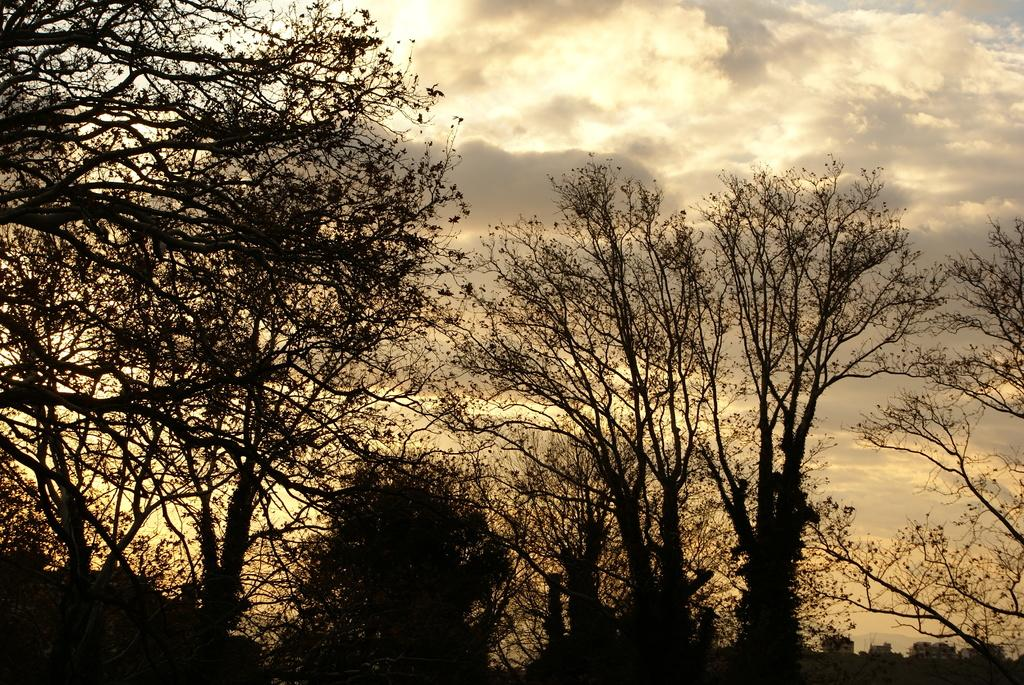What can be seen in the background of the image? The sky is visible in the background of the image. How would you describe the sky in the image? The sky appears to be cloudy. What is the main focus of the image? Trees are the main highlight of the image. What type of game is being played in the image? There is no game being played in the image; it primarily features trees and a cloudy sky. How many screws can be seen in the image? There are no screws present in the image. 